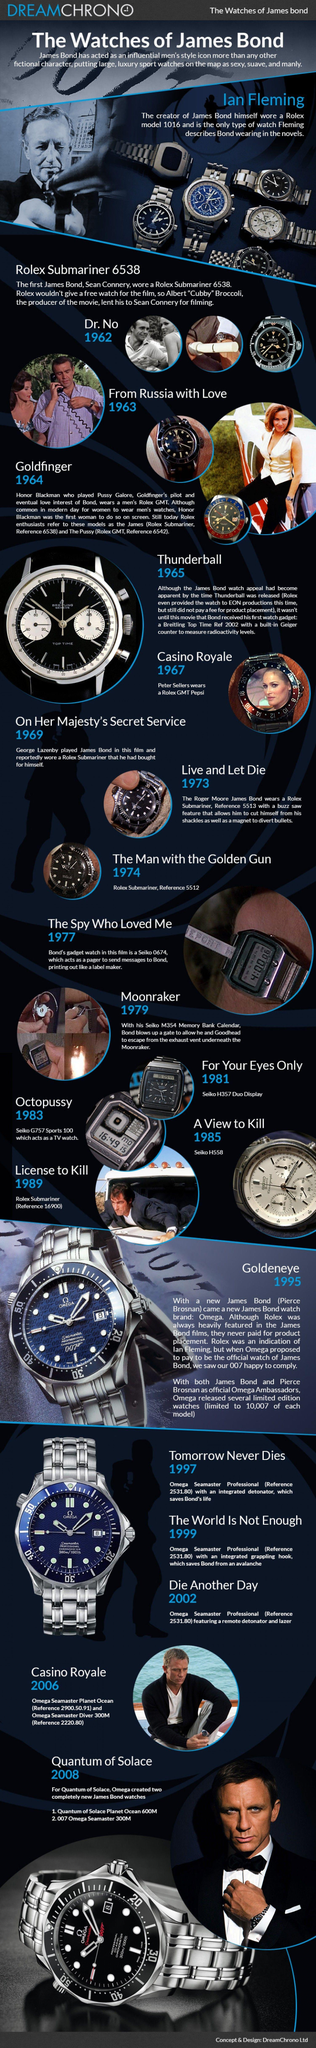Which watch was worn by Ian Fleming?
Answer the question with a short phrase. Rolex model 1016 Which actress wore Rolex on scree? Honor Blackman 